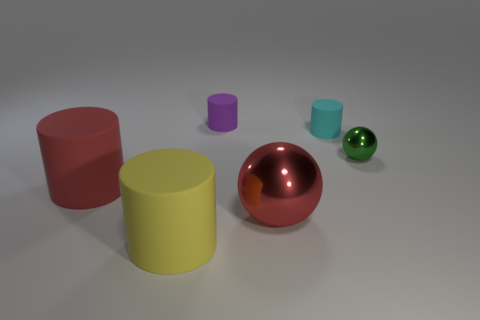Subtract 1 cylinders. How many cylinders are left? 3 Add 2 big red things. How many objects exist? 8 Subtract all balls. How many objects are left? 4 Subtract 0 purple spheres. How many objects are left? 6 Subtract all purple metallic balls. Subtract all green metallic spheres. How many objects are left? 5 Add 3 tiny cylinders. How many tiny cylinders are left? 5 Add 6 big gray metallic spheres. How many big gray metallic spheres exist? 6 